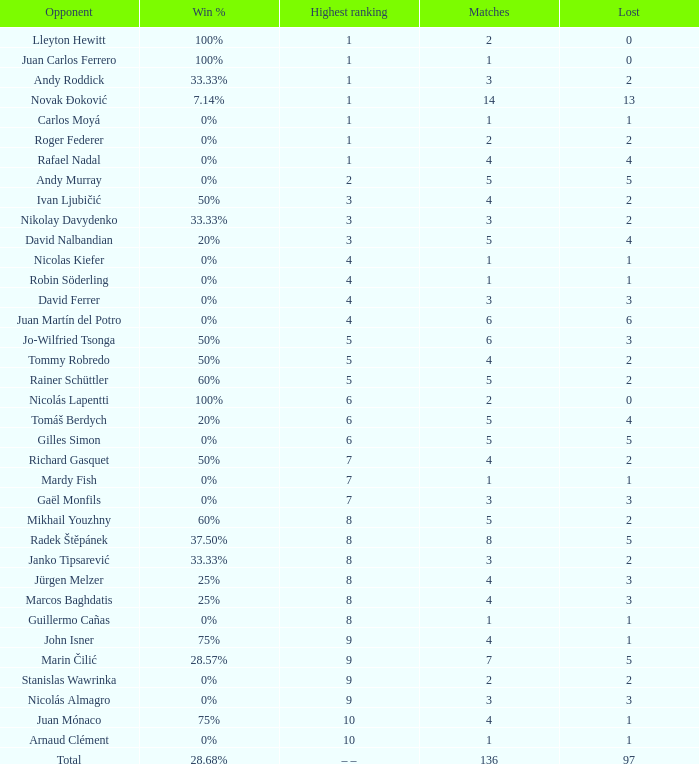What is the smallest number of Matches with less than 97 losses and a Win rate of 28.68%? None. 